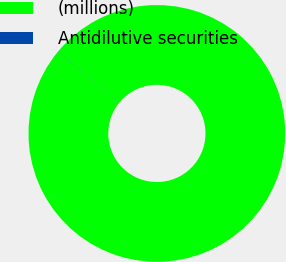Convert chart to OTSL. <chart><loc_0><loc_0><loc_500><loc_500><pie_chart><fcel>(millions)<fcel>Antidilutive securities<nl><fcel>99.98%<fcel>0.02%<nl></chart> 